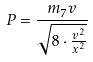Convert formula to latex. <formula><loc_0><loc_0><loc_500><loc_500>P = \frac { m _ { 7 } v } { \sqrt { 8 \cdot \frac { v ^ { 2 } } { x ^ { 2 } } } }</formula> 